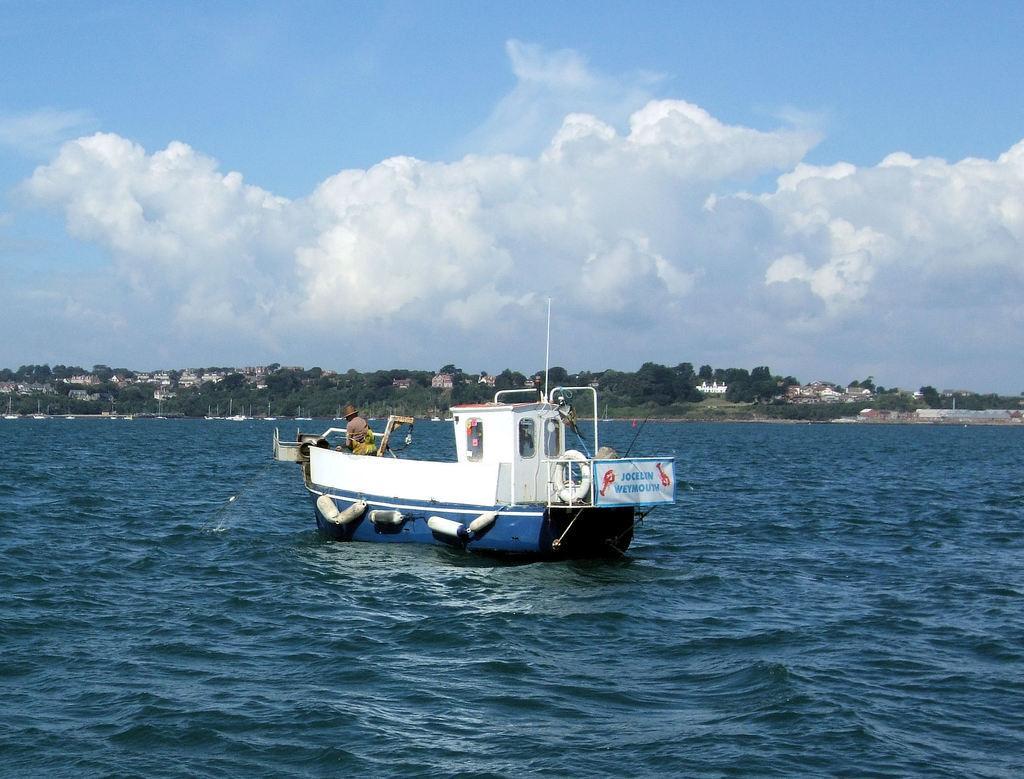Can you describe this image briefly? In this image we can see there is a person standing on the boat, which is on the river. In the background there are buildings, trees and sky. 